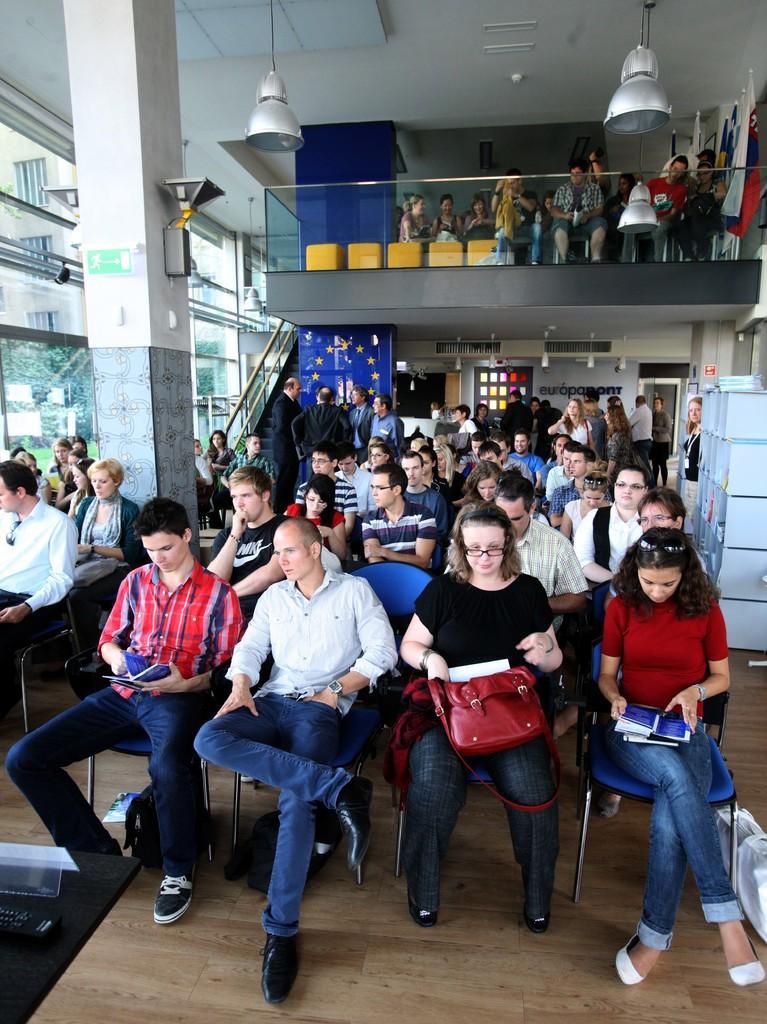Could you give a brief overview of what you see in this image? In this image we can see many people sitting on the chairs and holding some objects in their hands. There are many lights in the image. There are few object placed on the floor. There are few objects at the right side of the image. 